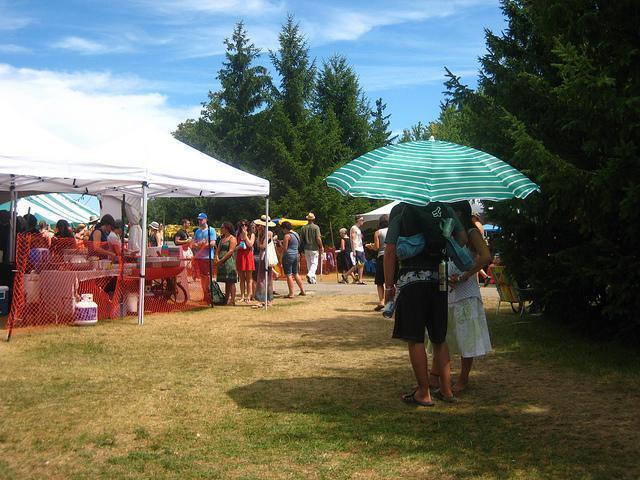What is the green umbrella being used to block?
Indicate the correct response by choosing from the four available options to answer the question.
Options: Sun, wind, bugs, rain. Sun. 